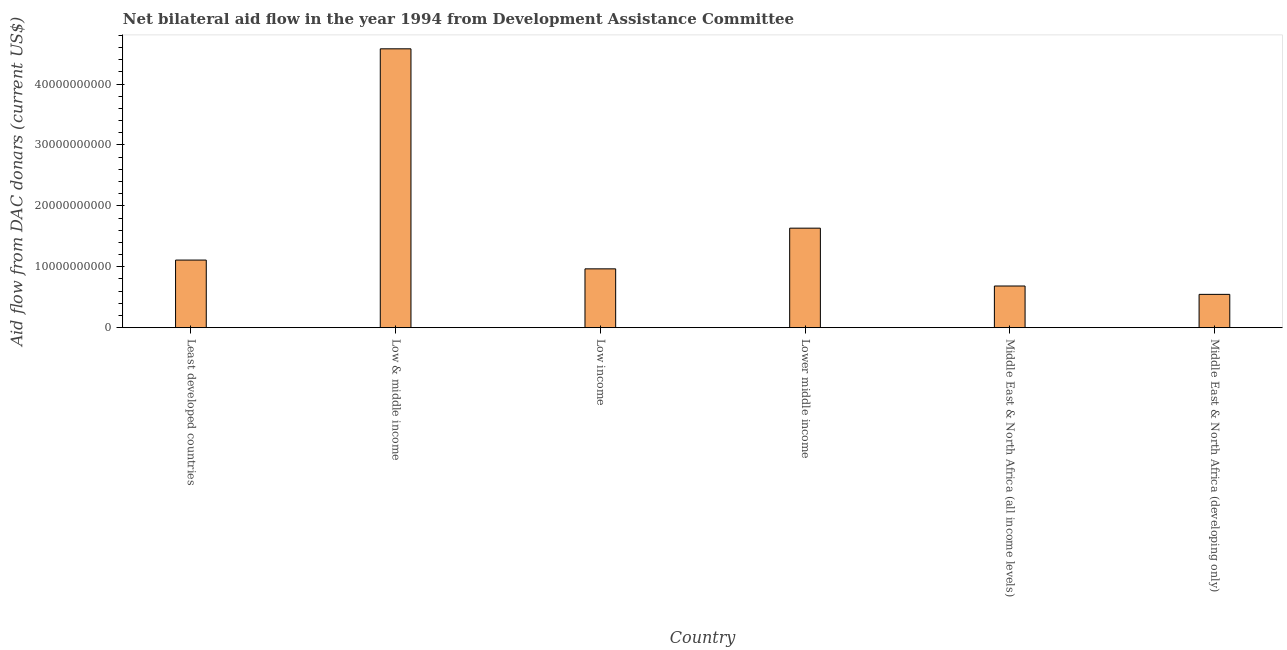What is the title of the graph?
Ensure brevity in your answer.  Net bilateral aid flow in the year 1994 from Development Assistance Committee. What is the label or title of the X-axis?
Ensure brevity in your answer.  Country. What is the label or title of the Y-axis?
Make the answer very short. Aid flow from DAC donars (current US$). What is the net bilateral aid flows from dac donors in Middle East & North Africa (developing only)?
Your response must be concise. 5.47e+09. Across all countries, what is the maximum net bilateral aid flows from dac donors?
Keep it short and to the point. 4.58e+1. Across all countries, what is the minimum net bilateral aid flows from dac donors?
Provide a succinct answer. 5.47e+09. In which country was the net bilateral aid flows from dac donors maximum?
Offer a very short reply. Low & middle income. In which country was the net bilateral aid flows from dac donors minimum?
Offer a very short reply. Middle East & North Africa (developing only). What is the sum of the net bilateral aid flows from dac donors?
Offer a very short reply. 9.52e+1. What is the difference between the net bilateral aid flows from dac donors in Low & middle income and Middle East & North Africa (developing only)?
Your response must be concise. 4.03e+1. What is the average net bilateral aid flows from dac donors per country?
Provide a short and direct response. 1.59e+1. What is the median net bilateral aid flows from dac donors?
Offer a terse response. 1.04e+1. In how many countries, is the net bilateral aid flows from dac donors greater than 40000000000 US$?
Keep it short and to the point. 1. What is the ratio of the net bilateral aid flows from dac donors in Least developed countries to that in Middle East & North Africa (developing only)?
Provide a succinct answer. 2.03. Is the difference between the net bilateral aid flows from dac donors in Least developed countries and Middle East & North Africa (developing only) greater than the difference between any two countries?
Make the answer very short. No. What is the difference between the highest and the second highest net bilateral aid flows from dac donors?
Provide a short and direct response. 2.94e+1. Is the sum of the net bilateral aid flows from dac donors in Low income and Lower middle income greater than the maximum net bilateral aid flows from dac donors across all countries?
Provide a succinct answer. No. What is the difference between the highest and the lowest net bilateral aid flows from dac donors?
Your answer should be compact. 4.03e+1. How many bars are there?
Your answer should be compact. 6. How many countries are there in the graph?
Keep it short and to the point. 6. What is the Aid flow from DAC donars (current US$) of Least developed countries?
Your answer should be very brief. 1.11e+1. What is the Aid flow from DAC donars (current US$) of Low & middle income?
Keep it short and to the point. 4.58e+1. What is the Aid flow from DAC donars (current US$) in Low income?
Provide a succinct answer. 9.66e+09. What is the Aid flow from DAC donars (current US$) in Lower middle income?
Your answer should be very brief. 1.63e+1. What is the Aid flow from DAC donars (current US$) of Middle East & North Africa (all income levels)?
Make the answer very short. 6.84e+09. What is the Aid flow from DAC donars (current US$) of Middle East & North Africa (developing only)?
Ensure brevity in your answer.  5.47e+09. What is the difference between the Aid flow from DAC donars (current US$) in Least developed countries and Low & middle income?
Provide a short and direct response. -3.47e+1. What is the difference between the Aid flow from DAC donars (current US$) in Least developed countries and Low income?
Keep it short and to the point. 1.44e+09. What is the difference between the Aid flow from DAC donars (current US$) in Least developed countries and Lower middle income?
Your answer should be very brief. -5.24e+09. What is the difference between the Aid flow from DAC donars (current US$) in Least developed countries and Middle East & North Africa (all income levels)?
Your answer should be compact. 4.26e+09. What is the difference between the Aid flow from DAC donars (current US$) in Least developed countries and Middle East & North Africa (developing only)?
Keep it short and to the point. 5.63e+09. What is the difference between the Aid flow from DAC donars (current US$) in Low & middle income and Low income?
Your answer should be very brief. 3.61e+1. What is the difference between the Aid flow from DAC donars (current US$) in Low & middle income and Lower middle income?
Your response must be concise. 2.94e+1. What is the difference between the Aid flow from DAC donars (current US$) in Low & middle income and Middle East & North Africa (all income levels)?
Your response must be concise. 3.89e+1. What is the difference between the Aid flow from DAC donars (current US$) in Low & middle income and Middle East & North Africa (developing only)?
Your answer should be compact. 4.03e+1. What is the difference between the Aid flow from DAC donars (current US$) in Low income and Lower middle income?
Offer a terse response. -6.68e+09. What is the difference between the Aid flow from DAC donars (current US$) in Low income and Middle East & North Africa (all income levels)?
Ensure brevity in your answer.  2.82e+09. What is the difference between the Aid flow from DAC donars (current US$) in Low income and Middle East & North Africa (developing only)?
Provide a succinct answer. 4.19e+09. What is the difference between the Aid flow from DAC donars (current US$) in Lower middle income and Middle East & North Africa (all income levels)?
Your response must be concise. 9.50e+09. What is the difference between the Aid flow from DAC donars (current US$) in Lower middle income and Middle East & North Africa (developing only)?
Ensure brevity in your answer.  1.09e+1. What is the difference between the Aid flow from DAC donars (current US$) in Middle East & North Africa (all income levels) and Middle East & North Africa (developing only)?
Your answer should be very brief. 1.37e+09. What is the ratio of the Aid flow from DAC donars (current US$) in Least developed countries to that in Low & middle income?
Provide a short and direct response. 0.24. What is the ratio of the Aid flow from DAC donars (current US$) in Least developed countries to that in Low income?
Offer a terse response. 1.15. What is the ratio of the Aid flow from DAC donars (current US$) in Least developed countries to that in Lower middle income?
Offer a very short reply. 0.68. What is the ratio of the Aid flow from DAC donars (current US$) in Least developed countries to that in Middle East & North Africa (all income levels)?
Offer a terse response. 1.62. What is the ratio of the Aid flow from DAC donars (current US$) in Least developed countries to that in Middle East & North Africa (developing only)?
Make the answer very short. 2.03. What is the ratio of the Aid flow from DAC donars (current US$) in Low & middle income to that in Low income?
Ensure brevity in your answer.  4.74. What is the ratio of the Aid flow from DAC donars (current US$) in Low & middle income to that in Lower middle income?
Keep it short and to the point. 2.8. What is the ratio of the Aid flow from DAC donars (current US$) in Low & middle income to that in Middle East & North Africa (all income levels)?
Offer a terse response. 6.69. What is the ratio of the Aid flow from DAC donars (current US$) in Low & middle income to that in Middle East & North Africa (developing only)?
Give a very brief answer. 8.38. What is the ratio of the Aid flow from DAC donars (current US$) in Low income to that in Lower middle income?
Provide a succinct answer. 0.59. What is the ratio of the Aid flow from DAC donars (current US$) in Low income to that in Middle East & North Africa (all income levels)?
Keep it short and to the point. 1.41. What is the ratio of the Aid flow from DAC donars (current US$) in Low income to that in Middle East & North Africa (developing only)?
Ensure brevity in your answer.  1.77. What is the ratio of the Aid flow from DAC donars (current US$) in Lower middle income to that in Middle East & North Africa (all income levels)?
Give a very brief answer. 2.39. What is the ratio of the Aid flow from DAC donars (current US$) in Lower middle income to that in Middle East & North Africa (developing only)?
Offer a very short reply. 2.99. What is the ratio of the Aid flow from DAC donars (current US$) in Middle East & North Africa (all income levels) to that in Middle East & North Africa (developing only)?
Ensure brevity in your answer.  1.25. 